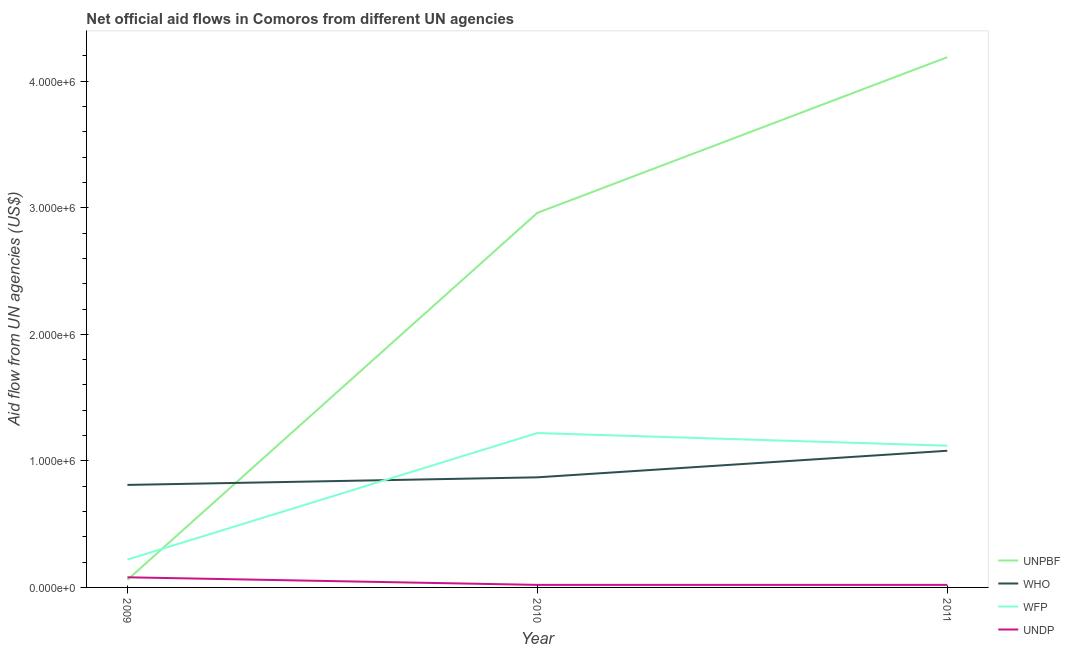Is the number of lines equal to the number of legend labels?
Provide a succinct answer. Yes. What is the amount of aid given by unpbf in 2009?
Make the answer very short. 6.00e+04. Across all years, what is the maximum amount of aid given by unpbf?
Ensure brevity in your answer.  4.19e+06. Across all years, what is the minimum amount of aid given by who?
Your answer should be compact. 8.10e+05. In which year was the amount of aid given by wfp maximum?
Your answer should be compact. 2010. What is the total amount of aid given by unpbf in the graph?
Provide a short and direct response. 7.21e+06. What is the difference between the amount of aid given by who in 2009 and that in 2011?
Your answer should be very brief. -2.70e+05. What is the difference between the amount of aid given by who in 2009 and the amount of aid given by unpbf in 2010?
Offer a terse response. -2.15e+06. What is the average amount of aid given by wfp per year?
Give a very brief answer. 8.53e+05. In the year 2010, what is the difference between the amount of aid given by unpbf and amount of aid given by wfp?
Make the answer very short. 1.74e+06. What is the ratio of the amount of aid given by who in 2009 to that in 2010?
Offer a very short reply. 0.93. What is the difference between the highest and the second highest amount of aid given by unpbf?
Offer a very short reply. 1.23e+06. What is the difference between the highest and the lowest amount of aid given by wfp?
Offer a terse response. 1.00e+06. In how many years, is the amount of aid given by wfp greater than the average amount of aid given by wfp taken over all years?
Your answer should be very brief. 2. Is the sum of the amount of aid given by who in 2010 and 2011 greater than the maximum amount of aid given by wfp across all years?
Offer a very short reply. Yes. Is it the case that in every year, the sum of the amount of aid given by wfp and amount of aid given by undp is greater than the sum of amount of aid given by who and amount of aid given by unpbf?
Keep it short and to the point. No. How many lines are there?
Keep it short and to the point. 4. Are the values on the major ticks of Y-axis written in scientific E-notation?
Provide a succinct answer. Yes. Does the graph contain any zero values?
Keep it short and to the point. No. Does the graph contain grids?
Provide a succinct answer. No. Where does the legend appear in the graph?
Provide a succinct answer. Bottom right. How many legend labels are there?
Offer a terse response. 4. How are the legend labels stacked?
Make the answer very short. Vertical. What is the title of the graph?
Offer a terse response. Net official aid flows in Comoros from different UN agencies. What is the label or title of the Y-axis?
Provide a short and direct response. Aid flow from UN agencies (US$). What is the Aid flow from UN agencies (US$) of UNPBF in 2009?
Your answer should be compact. 6.00e+04. What is the Aid flow from UN agencies (US$) of WHO in 2009?
Give a very brief answer. 8.10e+05. What is the Aid flow from UN agencies (US$) of UNPBF in 2010?
Offer a very short reply. 2.96e+06. What is the Aid flow from UN agencies (US$) of WHO in 2010?
Ensure brevity in your answer.  8.70e+05. What is the Aid flow from UN agencies (US$) of WFP in 2010?
Keep it short and to the point. 1.22e+06. What is the Aid flow from UN agencies (US$) of UNPBF in 2011?
Your answer should be very brief. 4.19e+06. What is the Aid flow from UN agencies (US$) in WHO in 2011?
Ensure brevity in your answer.  1.08e+06. What is the Aid flow from UN agencies (US$) in WFP in 2011?
Make the answer very short. 1.12e+06. Across all years, what is the maximum Aid flow from UN agencies (US$) of UNPBF?
Keep it short and to the point. 4.19e+06. Across all years, what is the maximum Aid flow from UN agencies (US$) in WHO?
Offer a terse response. 1.08e+06. Across all years, what is the maximum Aid flow from UN agencies (US$) of WFP?
Your answer should be very brief. 1.22e+06. Across all years, what is the minimum Aid flow from UN agencies (US$) of UNPBF?
Ensure brevity in your answer.  6.00e+04. Across all years, what is the minimum Aid flow from UN agencies (US$) in WHO?
Provide a short and direct response. 8.10e+05. Across all years, what is the minimum Aid flow from UN agencies (US$) of WFP?
Your answer should be very brief. 2.20e+05. Across all years, what is the minimum Aid flow from UN agencies (US$) in UNDP?
Your response must be concise. 2.00e+04. What is the total Aid flow from UN agencies (US$) in UNPBF in the graph?
Offer a very short reply. 7.21e+06. What is the total Aid flow from UN agencies (US$) of WHO in the graph?
Your answer should be very brief. 2.76e+06. What is the total Aid flow from UN agencies (US$) of WFP in the graph?
Your answer should be very brief. 2.56e+06. What is the total Aid flow from UN agencies (US$) of UNDP in the graph?
Your answer should be very brief. 1.20e+05. What is the difference between the Aid flow from UN agencies (US$) of UNPBF in 2009 and that in 2010?
Provide a succinct answer. -2.90e+06. What is the difference between the Aid flow from UN agencies (US$) in WFP in 2009 and that in 2010?
Ensure brevity in your answer.  -1.00e+06. What is the difference between the Aid flow from UN agencies (US$) in UNPBF in 2009 and that in 2011?
Offer a very short reply. -4.13e+06. What is the difference between the Aid flow from UN agencies (US$) in WHO in 2009 and that in 2011?
Your answer should be very brief. -2.70e+05. What is the difference between the Aid flow from UN agencies (US$) of WFP in 2009 and that in 2011?
Give a very brief answer. -9.00e+05. What is the difference between the Aid flow from UN agencies (US$) in UNDP in 2009 and that in 2011?
Keep it short and to the point. 6.00e+04. What is the difference between the Aid flow from UN agencies (US$) of UNPBF in 2010 and that in 2011?
Ensure brevity in your answer.  -1.23e+06. What is the difference between the Aid flow from UN agencies (US$) of WFP in 2010 and that in 2011?
Keep it short and to the point. 1.00e+05. What is the difference between the Aid flow from UN agencies (US$) of UNPBF in 2009 and the Aid flow from UN agencies (US$) of WHO in 2010?
Provide a succinct answer. -8.10e+05. What is the difference between the Aid flow from UN agencies (US$) in UNPBF in 2009 and the Aid flow from UN agencies (US$) in WFP in 2010?
Give a very brief answer. -1.16e+06. What is the difference between the Aid flow from UN agencies (US$) of UNPBF in 2009 and the Aid flow from UN agencies (US$) of UNDP in 2010?
Offer a very short reply. 4.00e+04. What is the difference between the Aid flow from UN agencies (US$) in WHO in 2009 and the Aid flow from UN agencies (US$) in WFP in 2010?
Give a very brief answer. -4.10e+05. What is the difference between the Aid flow from UN agencies (US$) of WHO in 2009 and the Aid flow from UN agencies (US$) of UNDP in 2010?
Your answer should be very brief. 7.90e+05. What is the difference between the Aid flow from UN agencies (US$) in WFP in 2009 and the Aid flow from UN agencies (US$) in UNDP in 2010?
Provide a short and direct response. 2.00e+05. What is the difference between the Aid flow from UN agencies (US$) in UNPBF in 2009 and the Aid flow from UN agencies (US$) in WHO in 2011?
Offer a terse response. -1.02e+06. What is the difference between the Aid flow from UN agencies (US$) of UNPBF in 2009 and the Aid flow from UN agencies (US$) of WFP in 2011?
Your response must be concise. -1.06e+06. What is the difference between the Aid flow from UN agencies (US$) in WHO in 2009 and the Aid flow from UN agencies (US$) in WFP in 2011?
Offer a terse response. -3.10e+05. What is the difference between the Aid flow from UN agencies (US$) of WHO in 2009 and the Aid flow from UN agencies (US$) of UNDP in 2011?
Keep it short and to the point. 7.90e+05. What is the difference between the Aid flow from UN agencies (US$) in UNPBF in 2010 and the Aid flow from UN agencies (US$) in WHO in 2011?
Ensure brevity in your answer.  1.88e+06. What is the difference between the Aid flow from UN agencies (US$) of UNPBF in 2010 and the Aid flow from UN agencies (US$) of WFP in 2011?
Your response must be concise. 1.84e+06. What is the difference between the Aid flow from UN agencies (US$) in UNPBF in 2010 and the Aid flow from UN agencies (US$) in UNDP in 2011?
Offer a very short reply. 2.94e+06. What is the difference between the Aid flow from UN agencies (US$) of WHO in 2010 and the Aid flow from UN agencies (US$) of WFP in 2011?
Provide a short and direct response. -2.50e+05. What is the difference between the Aid flow from UN agencies (US$) of WHO in 2010 and the Aid flow from UN agencies (US$) of UNDP in 2011?
Your answer should be very brief. 8.50e+05. What is the difference between the Aid flow from UN agencies (US$) of WFP in 2010 and the Aid flow from UN agencies (US$) of UNDP in 2011?
Keep it short and to the point. 1.20e+06. What is the average Aid flow from UN agencies (US$) of UNPBF per year?
Give a very brief answer. 2.40e+06. What is the average Aid flow from UN agencies (US$) in WHO per year?
Offer a very short reply. 9.20e+05. What is the average Aid flow from UN agencies (US$) of WFP per year?
Give a very brief answer. 8.53e+05. In the year 2009, what is the difference between the Aid flow from UN agencies (US$) of UNPBF and Aid flow from UN agencies (US$) of WHO?
Offer a very short reply. -7.50e+05. In the year 2009, what is the difference between the Aid flow from UN agencies (US$) in WHO and Aid flow from UN agencies (US$) in WFP?
Provide a short and direct response. 5.90e+05. In the year 2009, what is the difference between the Aid flow from UN agencies (US$) in WHO and Aid flow from UN agencies (US$) in UNDP?
Provide a succinct answer. 7.30e+05. In the year 2010, what is the difference between the Aid flow from UN agencies (US$) in UNPBF and Aid flow from UN agencies (US$) in WHO?
Your answer should be compact. 2.09e+06. In the year 2010, what is the difference between the Aid flow from UN agencies (US$) of UNPBF and Aid flow from UN agencies (US$) of WFP?
Your answer should be very brief. 1.74e+06. In the year 2010, what is the difference between the Aid flow from UN agencies (US$) in UNPBF and Aid flow from UN agencies (US$) in UNDP?
Offer a terse response. 2.94e+06. In the year 2010, what is the difference between the Aid flow from UN agencies (US$) in WHO and Aid flow from UN agencies (US$) in WFP?
Keep it short and to the point. -3.50e+05. In the year 2010, what is the difference between the Aid flow from UN agencies (US$) in WHO and Aid flow from UN agencies (US$) in UNDP?
Provide a short and direct response. 8.50e+05. In the year 2010, what is the difference between the Aid flow from UN agencies (US$) in WFP and Aid flow from UN agencies (US$) in UNDP?
Your answer should be compact. 1.20e+06. In the year 2011, what is the difference between the Aid flow from UN agencies (US$) of UNPBF and Aid flow from UN agencies (US$) of WHO?
Your answer should be compact. 3.11e+06. In the year 2011, what is the difference between the Aid flow from UN agencies (US$) of UNPBF and Aid flow from UN agencies (US$) of WFP?
Make the answer very short. 3.07e+06. In the year 2011, what is the difference between the Aid flow from UN agencies (US$) of UNPBF and Aid flow from UN agencies (US$) of UNDP?
Provide a succinct answer. 4.17e+06. In the year 2011, what is the difference between the Aid flow from UN agencies (US$) in WHO and Aid flow from UN agencies (US$) in WFP?
Offer a very short reply. -4.00e+04. In the year 2011, what is the difference between the Aid flow from UN agencies (US$) of WHO and Aid flow from UN agencies (US$) of UNDP?
Provide a succinct answer. 1.06e+06. In the year 2011, what is the difference between the Aid flow from UN agencies (US$) of WFP and Aid flow from UN agencies (US$) of UNDP?
Your answer should be very brief. 1.10e+06. What is the ratio of the Aid flow from UN agencies (US$) in UNPBF in 2009 to that in 2010?
Your answer should be compact. 0.02. What is the ratio of the Aid flow from UN agencies (US$) of WFP in 2009 to that in 2010?
Give a very brief answer. 0.18. What is the ratio of the Aid flow from UN agencies (US$) in UNPBF in 2009 to that in 2011?
Give a very brief answer. 0.01. What is the ratio of the Aid flow from UN agencies (US$) of WHO in 2009 to that in 2011?
Give a very brief answer. 0.75. What is the ratio of the Aid flow from UN agencies (US$) in WFP in 2009 to that in 2011?
Offer a very short reply. 0.2. What is the ratio of the Aid flow from UN agencies (US$) of UNPBF in 2010 to that in 2011?
Your answer should be very brief. 0.71. What is the ratio of the Aid flow from UN agencies (US$) in WHO in 2010 to that in 2011?
Ensure brevity in your answer.  0.81. What is the ratio of the Aid flow from UN agencies (US$) in WFP in 2010 to that in 2011?
Provide a short and direct response. 1.09. What is the difference between the highest and the second highest Aid flow from UN agencies (US$) of UNPBF?
Your response must be concise. 1.23e+06. What is the difference between the highest and the second highest Aid flow from UN agencies (US$) of WHO?
Give a very brief answer. 2.10e+05. What is the difference between the highest and the second highest Aid flow from UN agencies (US$) in WFP?
Provide a short and direct response. 1.00e+05. What is the difference between the highest and the lowest Aid flow from UN agencies (US$) in UNPBF?
Offer a terse response. 4.13e+06. What is the difference between the highest and the lowest Aid flow from UN agencies (US$) in WFP?
Give a very brief answer. 1.00e+06. 